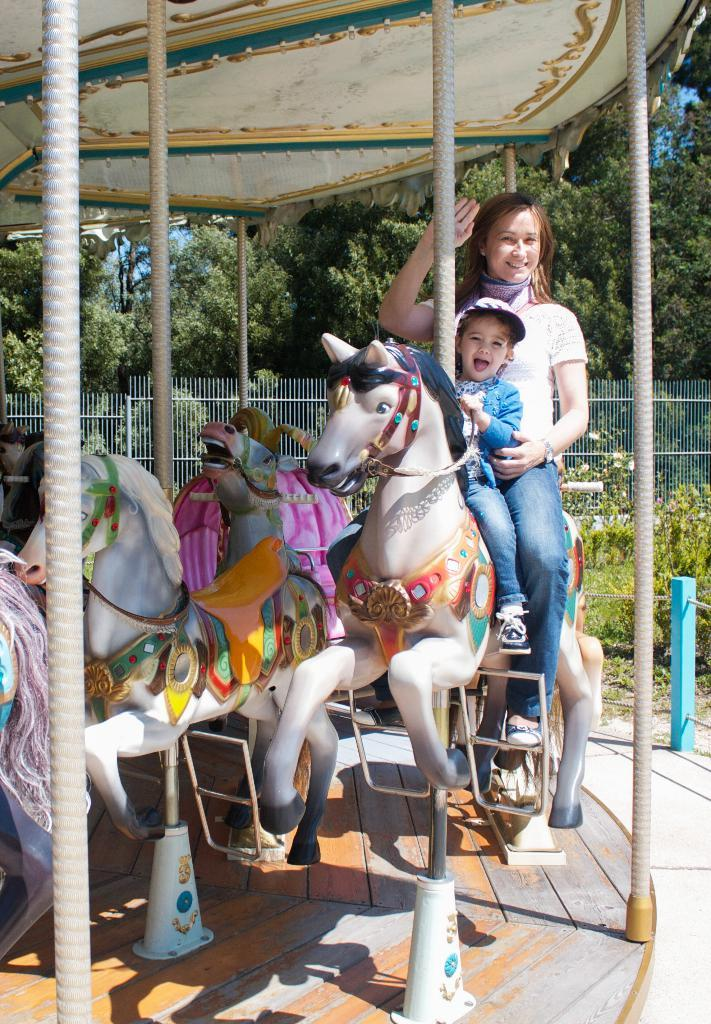How many people are in the image? There are 2 people in the image. What are the people doing in the image? The people are sitting on a carousel. What type of vegetation can be seen in the image? There are plants and trees in the image. What architectural feature is present in the image? There is a fence in the image. Where is the shelf located in the image? There is no shelf present in the image. What is the height of the end of the carousel in the image? The image does not provide information about the height of the carousel or any specific part of it. 